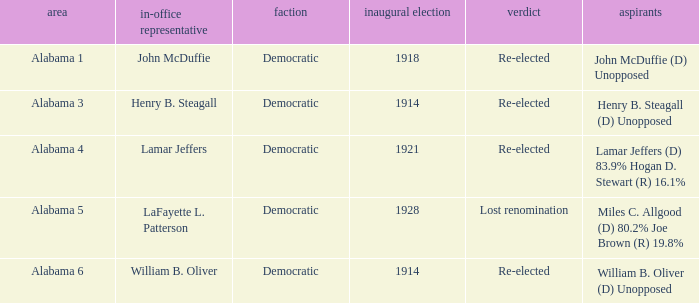How many in total were elected first in lost renomination? 1.0. 